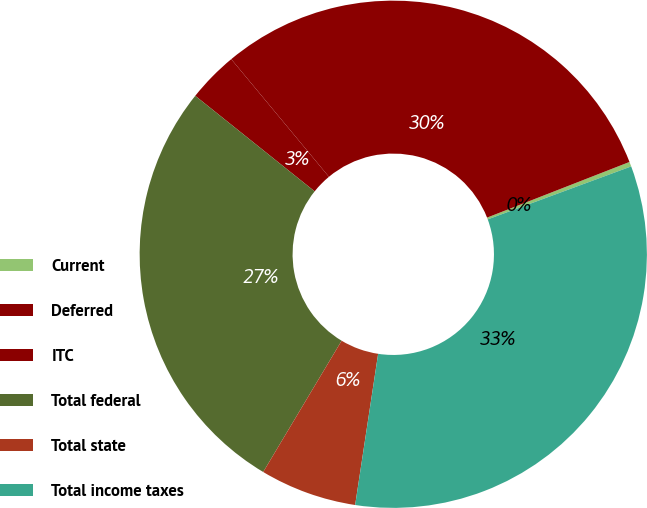<chart> <loc_0><loc_0><loc_500><loc_500><pie_chart><fcel>Current<fcel>Deferred<fcel>ITC<fcel>Total federal<fcel>Total state<fcel>Total income taxes<nl><fcel>0.3%<fcel>30.1%<fcel>3.23%<fcel>27.17%<fcel>6.17%<fcel>33.03%<nl></chart> 